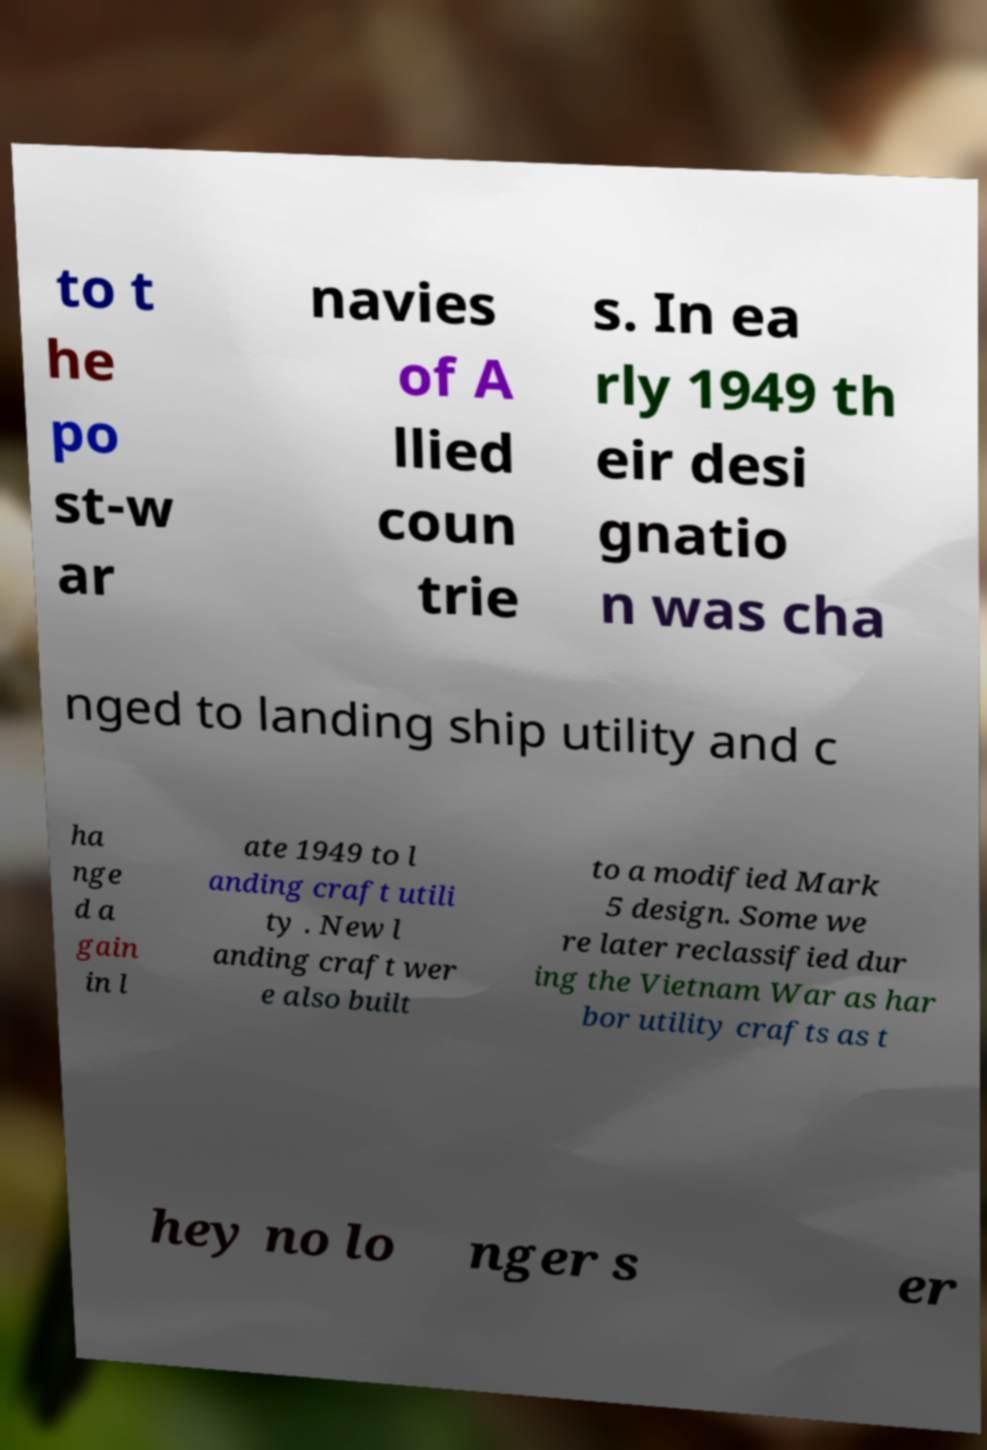There's text embedded in this image that I need extracted. Can you transcribe it verbatim? to t he po st-w ar navies of A llied coun trie s. In ea rly 1949 th eir desi gnatio n was cha nged to landing ship utility and c ha nge d a gain in l ate 1949 to l anding craft utili ty . New l anding craft wer e also built to a modified Mark 5 design. Some we re later reclassified dur ing the Vietnam War as har bor utility crafts as t hey no lo nger s er 